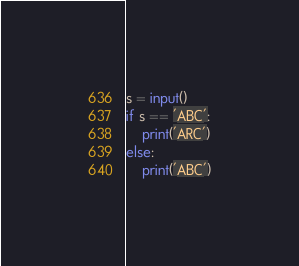Convert code to text. <code><loc_0><loc_0><loc_500><loc_500><_Python_>s = input()
if s == 'ABC':
    print('ARC')
else:
    print('ABC')</code> 